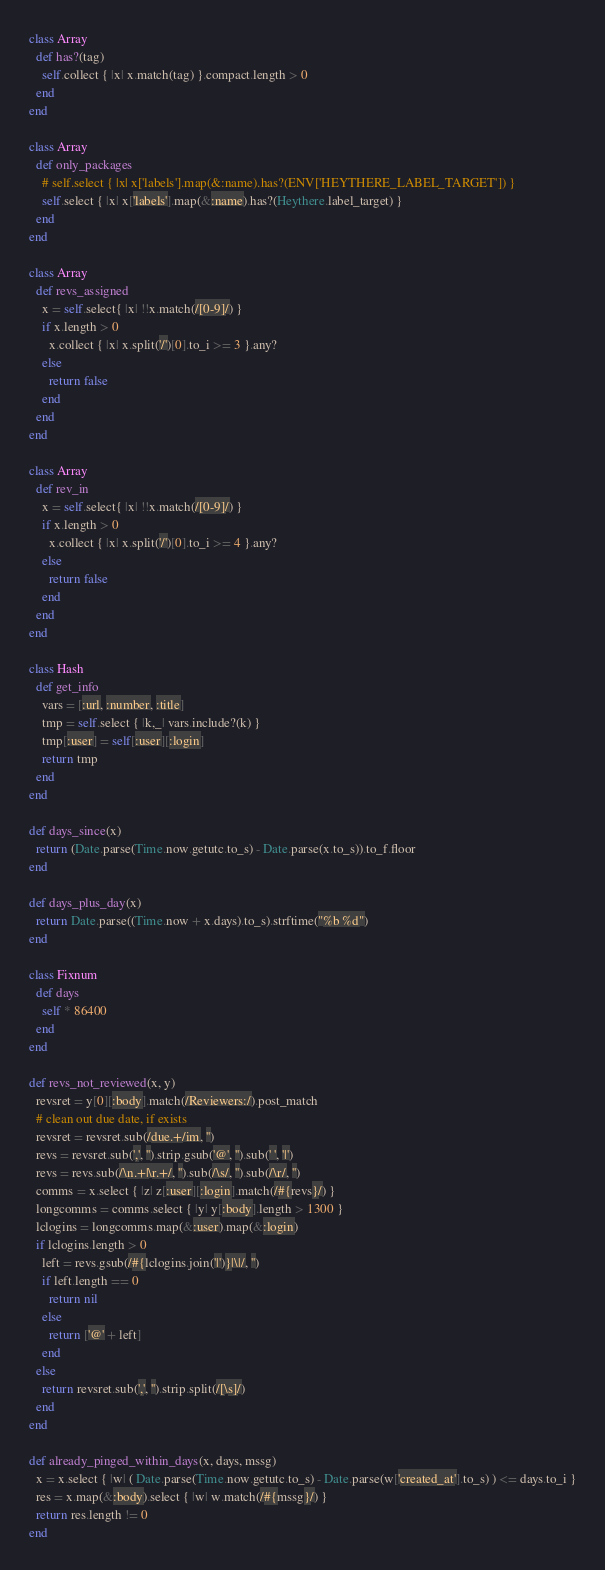Convert code to text. <code><loc_0><loc_0><loc_500><loc_500><_Ruby_>class Array
  def has?(tag)
    self.collect { |x| x.match(tag) }.compact.length > 0
  end
end

class Array
  def only_packages
    # self.select { |x| x['labels'].map(&:name).has?(ENV['HEYTHERE_LABEL_TARGET']) }
    self.select { |x| x['labels'].map(&:name).has?(Heythere.label_target) }
  end
end

class Array
  def revs_assigned
    x = self.select{ |x| !!x.match(/[0-9]/) }
    if x.length > 0
      x.collect { |x| x.split('/')[0].to_i >= 3 }.any?
    else
      return false
    end
  end
end

class Array
  def rev_in
    x = self.select{ |x| !!x.match(/[0-9]/) }
    if x.length > 0
      x.collect { |x| x.split('/')[0].to_i >= 4 }.any?
    else
      return false
    end
  end
end

class Hash
  def get_info
    vars = [:url, :number, :title]
    tmp = self.select { |k,_| vars.include?(k) }
    tmp[:user] = self[:user][:login]
    return tmp
  end
end

def days_since(x)
  return (Date.parse(Time.now.getutc.to_s) - Date.parse(x.to_s)).to_f.floor
end

def days_plus_day(x)
  return Date.parse((Time.now + x.days).to_s).strftime("%b %d")
end

class Fixnum
  def days
    self * 86400
  end
end

def revs_not_reviewed(x, y)
  revsret = y[0][:body].match(/Reviewers:/).post_match
  # clean out due date, if exists
  revsret = revsret.sub(/due.+/im, '')
  revs = revsret.sub(',', '').strip.gsub('@', '').sub(' ', '|')
  revs = revs.sub(/\n.+|\r.+/, '').sub(/\s/, '').sub(/\r/, '')
  comms = x.select { |z| z[:user][:login].match(/#{revs}/) }
  longcomms = comms.select { |y| y[:body].length > 1300 }
  lclogins = longcomms.map(&:user).map(&:login)
  if lclogins.length > 0
    left = revs.gsub(/#{lclogins.join('|')}|\|/, '')
    if left.length == 0
      return nil
    else
      return ['@' + left]
    end
  else
    return revsret.sub(',', '').strip.split(/[\s]/)
  end
end

def already_pinged_within_days(x, days, mssg)
  x = x.select { |w| ( Date.parse(Time.now.getutc.to_s) - Date.parse(w['created_at'].to_s) ) <= days.to_i }
  res = x.map(&:body).select { |w| w.match(/#{mssg}/) }
  return res.length != 0
end
</code> 